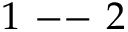Convert formula to latex. <formula><loc_0><loc_0><loc_500><loc_500>1 - - 2 \</formula> 